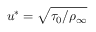<formula> <loc_0><loc_0><loc_500><loc_500>u ^ { * } = \sqrt { \tau _ { 0 } / \rho _ { \infty } }</formula> 